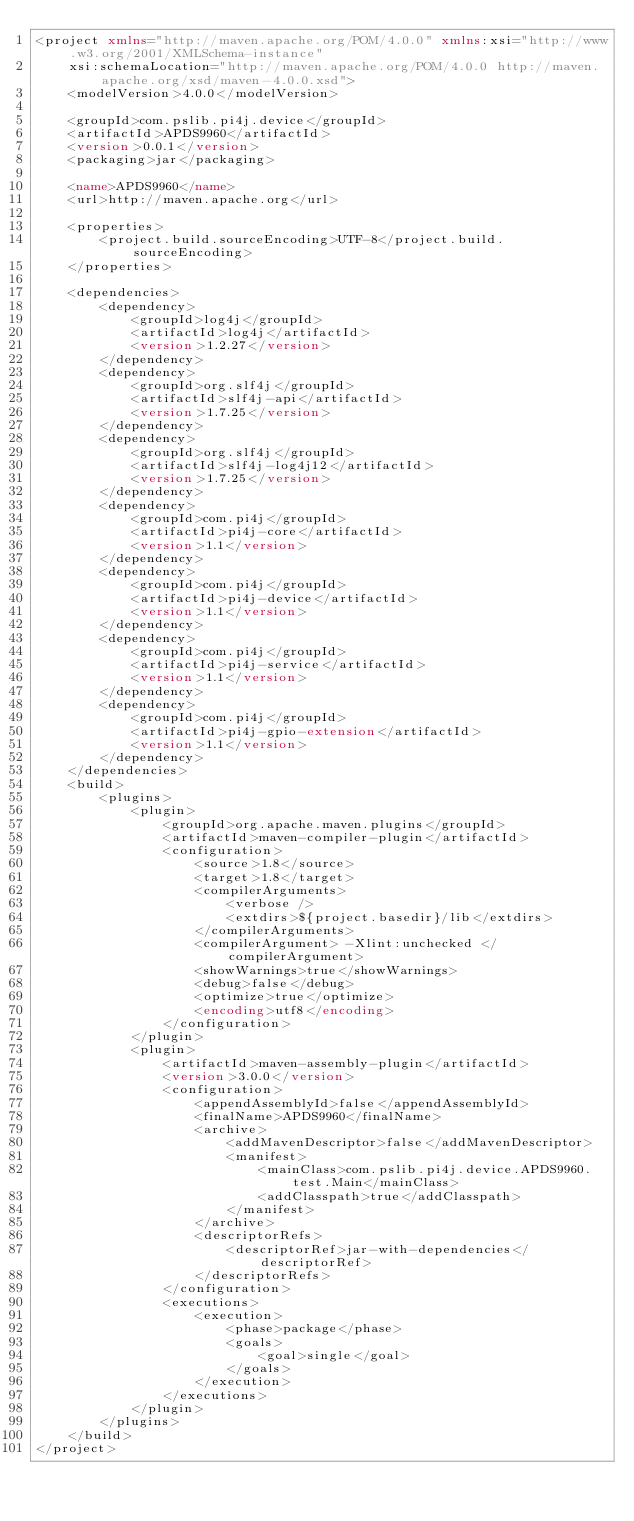<code> <loc_0><loc_0><loc_500><loc_500><_XML_><project xmlns="http://maven.apache.org/POM/4.0.0" xmlns:xsi="http://www.w3.org/2001/XMLSchema-instance"
	xsi:schemaLocation="http://maven.apache.org/POM/4.0.0 http://maven.apache.org/xsd/maven-4.0.0.xsd">
	<modelVersion>4.0.0</modelVersion>

	<groupId>com.pslib.pi4j.device</groupId>
	<artifactId>APDS9960</artifactId>
	<version>0.0.1</version>
	<packaging>jar</packaging>

	<name>APDS9960</name>
	<url>http://maven.apache.org</url>

	<properties>
		<project.build.sourceEncoding>UTF-8</project.build.sourceEncoding>
	</properties>

	<dependencies>
		<dependency>
			<groupId>log4j</groupId>
			<artifactId>log4j</artifactId>
			<version>1.2.27</version>
		</dependency>
		<dependency>
			<groupId>org.slf4j</groupId>
			<artifactId>slf4j-api</artifactId>
			<version>1.7.25</version>
		</dependency>
		<dependency>
			<groupId>org.slf4j</groupId>
			<artifactId>slf4j-log4j12</artifactId>
			<version>1.7.25</version>
		</dependency>
		<dependency>
			<groupId>com.pi4j</groupId>
			<artifactId>pi4j-core</artifactId>
			<version>1.1</version>
		</dependency>
		<dependency>
			<groupId>com.pi4j</groupId>
			<artifactId>pi4j-device</artifactId>
			<version>1.1</version>
		</dependency>
		<dependency>
			<groupId>com.pi4j</groupId>
			<artifactId>pi4j-service</artifactId>
			<version>1.1</version>
		</dependency>
		<dependency>
			<groupId>com.pi4j</groupId>
			<artifactId>pi4j-gpio-extension</artifactId>
			<version>1.1</version>
		</dependency>
	</dependencies>
	<build>
		<plugins>
			<plugin>
				<groupId>org.apache.maven.plugins</groupId>
				<artifactId>maven-compiler-plugin</artifactId>
				<configuration>
					<source>1.8</source>
					<target>1.8</target>
					<compilerArguments>
						<verbose />
						<extdirs>${project.basedir}/lib</extdirs>
					</compilerArguments>
					<compilerArgument> -Xlint:unchecked </compilerArgument>
					<showWarnings>true</showWarnings>
					<debug>false</debug>
					<optimize>true</optimize>
					<encoding>utf8</encoding>
				</configuration>
			</plugin>
			<plugin>
				<artifactId>maven-assembly-plugin</artifactId>
				<version>3.0.0</version>
				<configuration>
					<appendAssemblyId>false</appendAssemblyId>
					<finalName>APDS9960</finalName>
					<archive>
						<addMavenDescriptor>false</addMavenDescriptor>
						<manifest>
							<mainClass>com.pslib.pi4j.device.APDS9960.test.Main</mainClass>
							<addClasspath>true</addClasspath>
						</manifest>
					</archive>
					<descriptorRefs>
						<descriptorRef>jar-with-dependencies</descriptorRef>
					</descriptorRefs>
				</configuration>
				<executions>
					<execution>
						<phase>package</phase>
						<goals>
							<goal>single</goal>
						</goals>
					</execution>
				</executions>
			</plugin>
		</plugins>
	</build>
</project>
</code> 